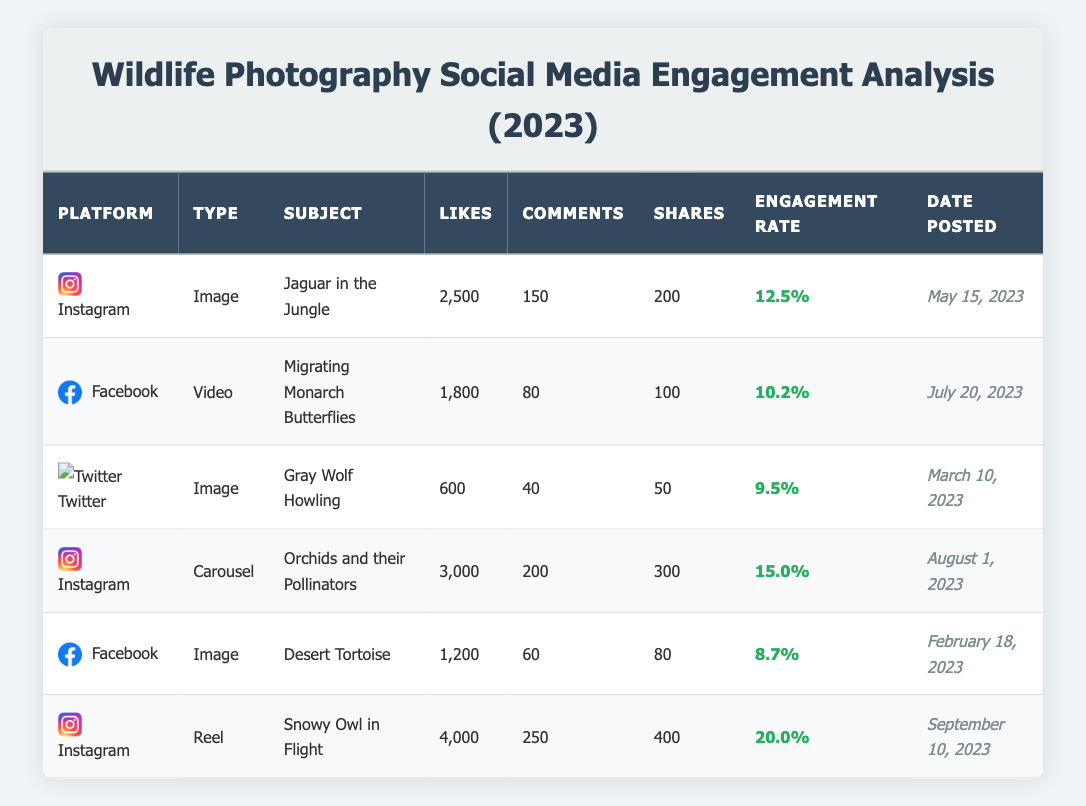What is the total number of likes for all posts on Instagram? The Instagram posts listed are: "Jaguar in the Jungle" (2,500 likes), "Orchids and their Pollinators" (3,000 likes), and "Snowy Owl in Flight" (4,000 likes). Summing these gives 2,500 + 3,000 + 4,000 = 9,500 likes.
Answer: 9,500 Which post received the most engagement rate? The engagement rates for each post are: "Jaguar in the Jungle" (12.5%), "Migrating Monarch Butterflies" (10.2%), "Gray Wolf Howling" (9.5%), "Orchids and their Pollinators" (15.0%), "Desert Tortoise" (8.7%), and "Snowy Owl in Flight" (20.0%). The highest engagement rate is 20.0% for "Snowy Owl in Flight".
Answer: 20.0% Did the "Desert Tortoise" image receive more likes than comments? The "Desert Tortoise" post received 1,200 likes and 60 comments. Since 1,200 is greater than 60, the statement is true.
Answer: Yes What is the average number of shares for all Facebook posts? The Facebook posts are: "Migrating Monarch Butterflies" (100 shares) and "Desert Tortoise" (80 shares). To find the average, sum the shares: 100 + 80 = 180, then divide by 2 (the number of posts) to get 180 / 2 = 90 shares.
Answer: 90 Which post was made first within the year? The posts were dated as follows: "Gray Wolf Howling" (March 10, 2023), "Desert Tortoise" (February 18, 2023), "Jaguar in the Jungle" (May 15, 2023), "Migrating Monarch Butterflies" (July 20, 2023), "Orchids and their Pollinators" (August 1, 2023), and "Snowy Owl in Flight" (September 10, 2023). The earliest date is February 18, 2023, for "Desert Tortoise".
Answer: "Desert Tortoise" What is the total number of comments across all posts? The number of comments for each post are as follows: "Jaguar in the Jungle" (150), "Migrating Monarch Butterflies" (80), "Gray Wolf Howling" (40), "Orchids and their Pollinators" (200), "Desert Tortoise" (60), and "Snowy Owl in Flight" (250). Summing these: 150 + 80 + 40 + 200 + 60 + 250 = 780 comments.
Answer: 780 